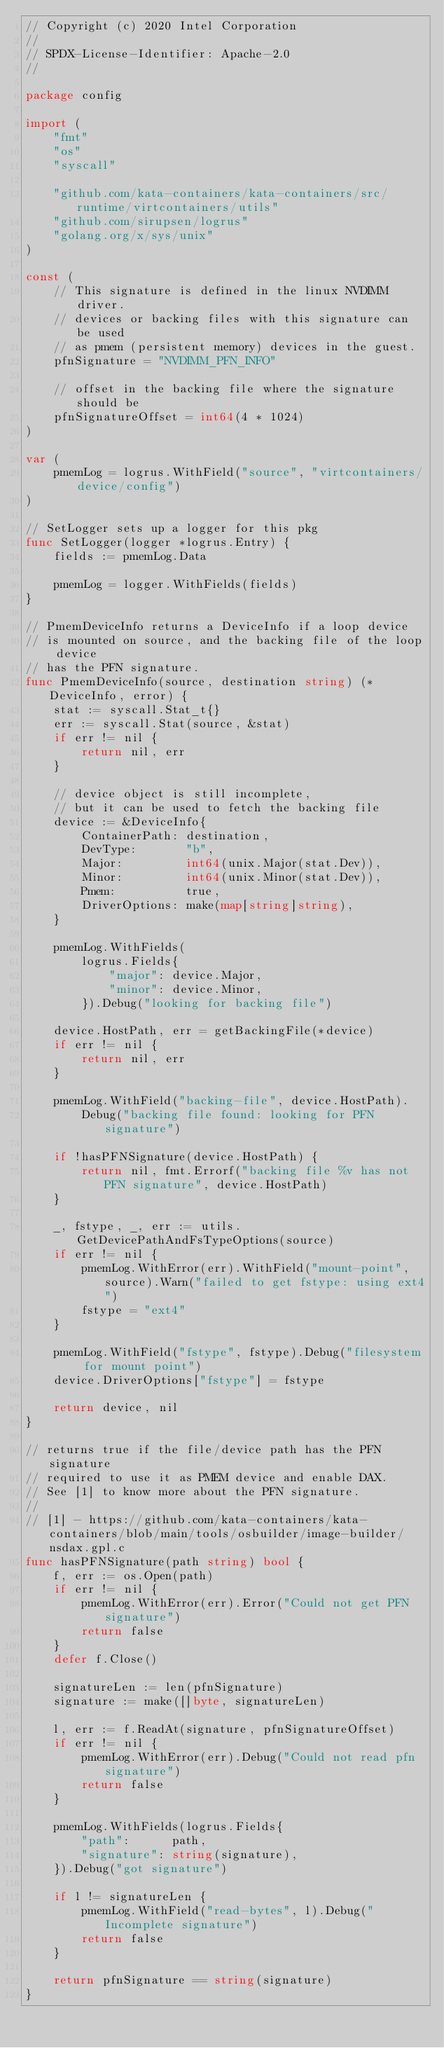Convert code to text. <code><loc_0><loc_0><loc_500><loc_500><_Go_>// Copyright (c) 2020 Intel Corporation
//
// SPDX-License-Identifier: Apache-2.0
//

package config

import (
	"fmt"
	"os"
	"syscall"

	"github.com/kata-containers/kata-containers/src/runtime/virtcontainers/utils"
	"github.com/sirupsen/logrus"
	"golang.org/x/sys/unix"
)

const (
	// This signature is defined in the linux NVDIMM driver.
	// devices or backing files with this signature can be used
	// as pmem (persistent memory) devices in the guest.
	pfnSignature = "NVDIMM_PFN_INFO"

	// offset in the backing file where the signature should be
	pfnSignatureOffset = int64(4 * 1024)
)

var (
	pmemLog = logrus.WithField("source", "virtcontainers/device/config")
)

// SetLogger sets up a logger for this pkg
func SetLogger(logger *logrus.Entry) {
	fields := pmemLog.Data

	pmemLog = logger.WithFields(fields)
}

// PmemDeviceInfo returns a DeviceInfo if a loop device
// is mounted on source, and the backing file of the loop device
// has the PFN signature.
func PmemDeviceInfo(source, destination string) (*DeviceInfo, error) {
	stat := syscall.Stat_t{}
	err := syscall.Stat(source, &stat)
	if err != nil {
		return nil, err
	}

	// device object is still incomplete,
	// but it can be used to fetch the backing file
	device := &DeviceInfo{
		ContainerPath: destination,
		DevType:       "b",
		Major:         int64(unix.Major(stat.Dev)),
		Minor:         int64(unix.Minor(stat.Dev)),
		Pmem:          true,
		DriverOptions: make(map[string]string),
	}

	pmemLog.WithFields(
		logrus.Fields{
			"major": device.Major,
			"minor": device.Minor,
		}).Debug("looking for backing file")

	device.HostPath, err = getBackingFile(*device)
	if err != nil {
		return nil, err
	}

	pmemLog.WithField("backing-file", device.HostPath).
		Debug("backing file found: looking for PFN signature")

	if !hasPFNSignature(device.HostPath) {
		return nil, fmt.Errorf("backing file %v has not PFN signature", device.HostPath)
	}

	_, fstype, _, err := utils.GetDevicePathAndFsTypeOptions(source)
	if err != nil {
		pmemLog.WithError(err).WithField("mount-point", source).Warn("failed to get fstype: using ext4")
		fstype = "ext4"
	}

	pmemLog.WithField("fstype", fstype).Debug("filesystem for mount point")
	device.DriverOptions["fstype"] = fstype

	return device, nil
}

// returns true if the file/device path has the PFN signature
// required to use it as PMEM device and enable DAX.
// See [1] to know more about the PFN signature.
//
// [1] - https://github.com/kata-containers/kata-containers/blob/main/tools/osbuilder/image-builder/nsdax.gpl.c
func hasPFNSignature(path string) bool {
	f, err := os.Open(path)
	if err != nil {
		pmemLog.WithError(err).Error("Could not get PFN signature")
		return false
	}
	defer f.Close()

	signatureLen := len(pfnSignature)
	signature := make([]byte, signatureLen)

	l, err := f.ReadAt(signature, pfnSignatureOffset)
	if err != nil {
		pmemLog.WithError(err).Debug("Could not read pfn signature")
		return false
	}

	pmemLog.WithFields(logrus.Fields{
		"path":      path,
		"signature": string(signature),
	}).Debug("got signature")

	if l != signatureLen {
		pmemLog.WithField("read-bytes", l).Debug("Incomplete signature")
		return false
	}

	return pfnSignature == string(signature)
}
</code> 